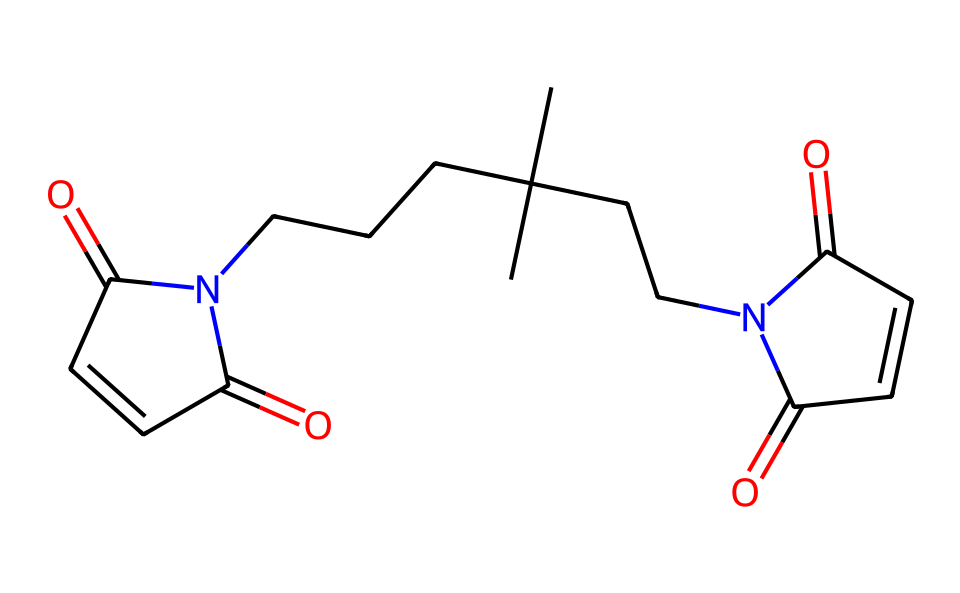What is the molecular formula of this compound? To find the molecular formula, count the number of each type of atom in the SMILES representation. This chemical contains 12 carbon (C) atoms, 14 hydrogen (H) atoms, 4 oxygen (O) atoms, and 2 nitrogen (N) atoms. So the molecular formula is C12H14N2O4.
Answer: C12H14N2O4 How many nitrogen atoms are present in this structure? By examining the SMILES notation, we can identify that there are two instances of nitrogen (N) in the structure. Therefore, the count of nitrogen atoms is 2.
Answer: 2 What type of functional groups are present in bismaleimide resins? The presence of multiple carbonyl groups (C=O) and amine groups (N-H) indicates the functional groups in bismaleimide resins, specifically imide and carbonyl structures.
Answer: imide and carbonyl How do the imide linkages contribute to the thermal stability of this resin? The imide linkages create strong covalent bonds due to resonance stabilization, which enhances the thermal stability of the resin. This reduces the likelihood of degradation at high temperatures.
Answer: resonance stabilization What characteristic makes bismaleimide suitable for high-temperature applications? The presence of strong imide bonds in the structure makes bismaleimide resins highly thermally stable and resistant to deformation under heat, making them ideal for high-temperature applications.
Answer: strong imide bonds What is the total number of double bonds in this molecule? By analyzing the SMILES representation, we can identify three double bonds present in the structure, each associated with the carbonyl and alkene parts of the molecule.
Answer: 3 